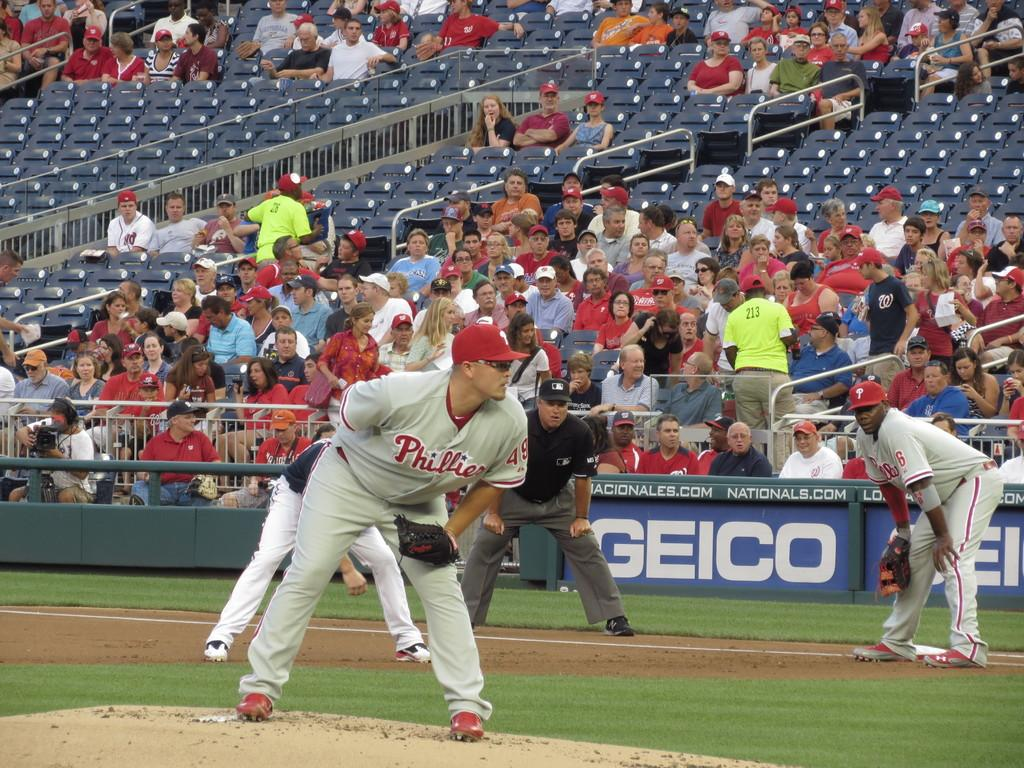Provide a one-sentence caption for the provided image. Baseball players playing a game with the company GEICO on a banner behind them. 